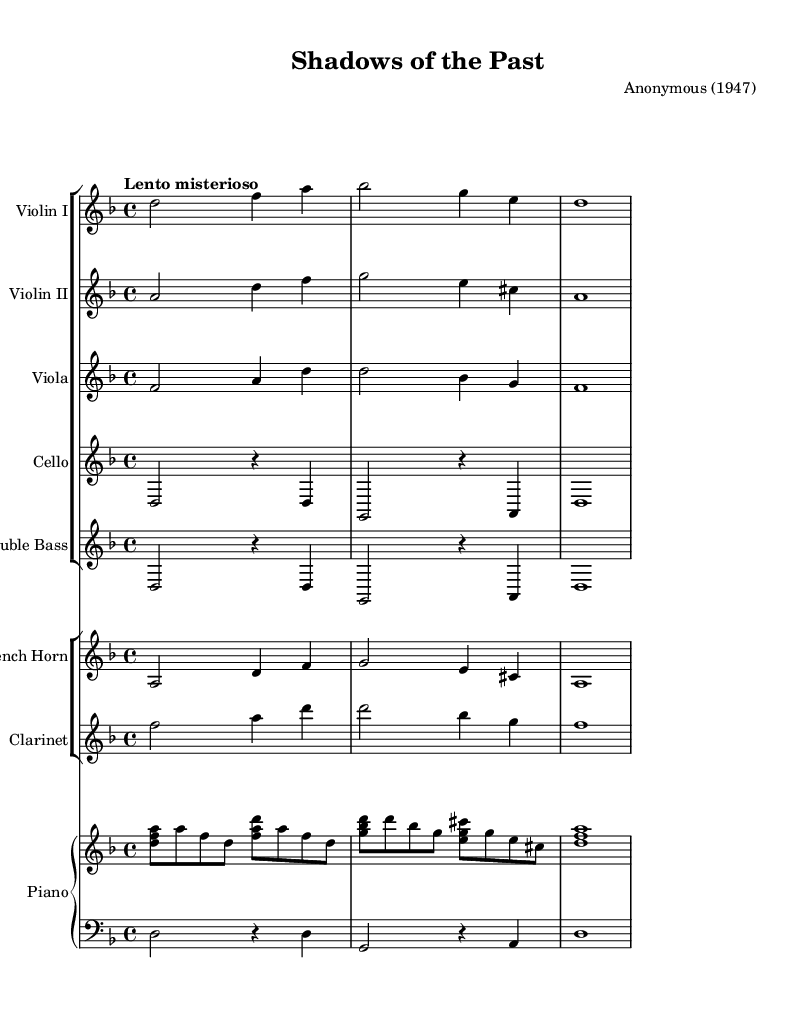What is the key signature of this music? The key signature is two flats, indicating B-flat major or G minor. It can be determined by looking at the key signature section at the beginning of the score.
Answer: B-flat What is the time signature of this piece? The time signature is indicated at the beginning of the score as 4/4, which shows that there are four beats in each measure. This is discernible by looking at the time signature symbol next to the clefs.
Answer: 4/4 What tempo marking is indicated for this piece? The tempo marking is "Lento misterioso," suggesting a slow and mysterious pace. This is found above the staff near the beginning of the score.
Answer: Lento misterioso How many instruments are scored in this piece? There are eight distinct instruments listed in the score as seen in the header and the stated instrument groups. By counting the instruments in the two groups (strings and winds, plus piano), we arrive at the total.
Answer: Eight Which instrument plays the melody in the opening measures? The melody is primarily played by the first violin, as identified by the notes in the first two measures of the Violin I staff, which presents the main theme.
Answer: Violin I What is the dynamic marking for the cello part throughout? The dynamic marking for the cello part is a whole note with no specified dynamics, implying a sustained and possibly softer sound. This can be inferred as there are no marked dynamics, suggesting a more subdued play.
Answer: No specific dynamics How many bars does the piano sustain the chord in the last part of the piece? The piano sustains the chord for a whole measure (four beats) in the last part of the score, indicated by the notation used in the right hand. This is evident in the layout of the notation at the end.
Answer: One bar 